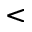Convert formula to latex. <formula><loc_0><loc_0><loc_500><loc_500><</formula> 